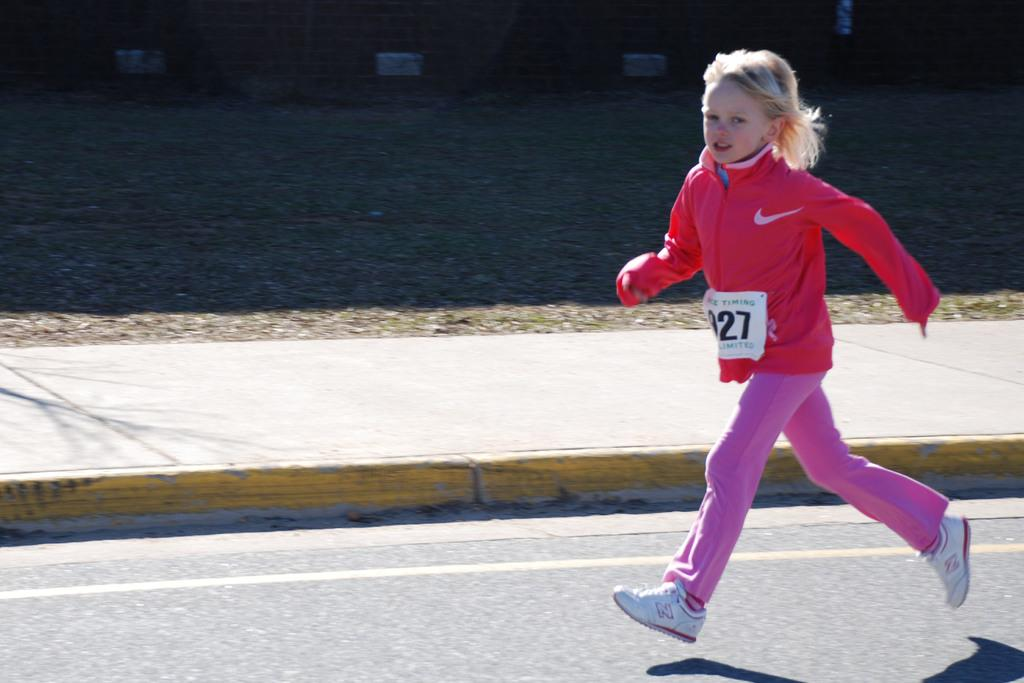Who is the main subject in the image? There is a girl in the image. What is the girl doing in the image? The girl is running in the image. Where is the girl located in the image? The girl is on the road in the image. What is the amount of religion present in the image? There is no mention of religion in the image, so it is not possible to determine the amount of religion present. 